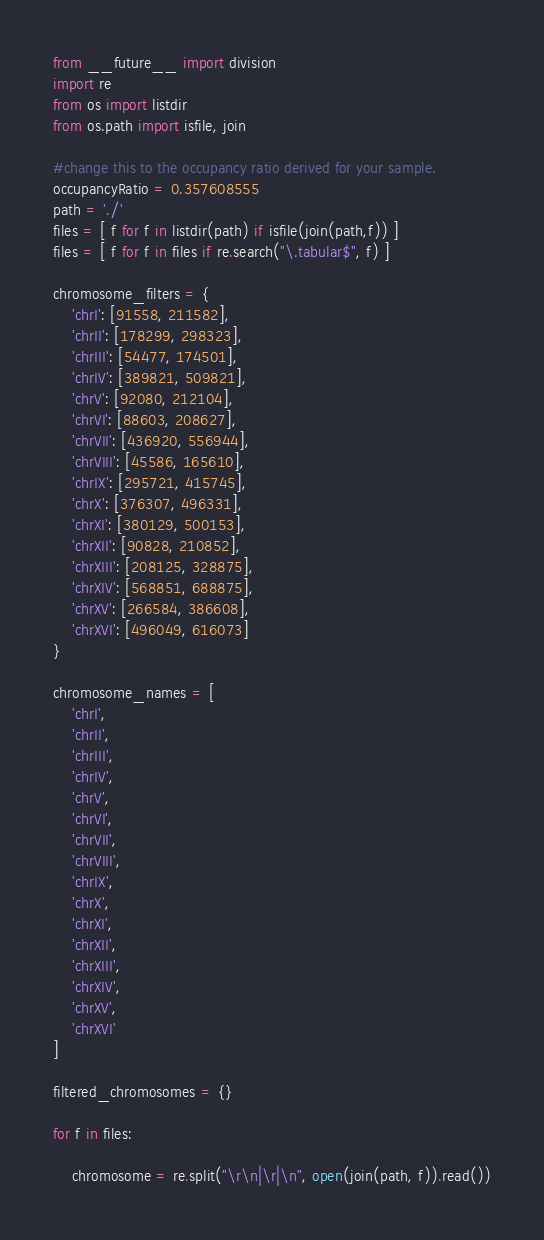Convert code to text. <code><loc_0><loc_0><loc_500><loc_500><_Python_>from __future__ import division
import re
from os import listdir
from os.path import isfile, join

#change this to the occupancy ratio derived for your sample.
occupancyRatio = 0.357608555
path = './'
files = [ f for f in listdir(path) if isfile(join(path,f)) ]
files = [ f for f in files if re.search("\.tabular$", f) ]

chromosome_filters = {
	'chrI': [91558, 211582],
	'chrII': [178299, 298323],
	'chrIII': [54477, 174501],
	'chrIV': [389821, 509821],
	'chrV': [92080, 212104],
	'chrVI': [88603, 208627],
	'chrVII': [436920, 556944],
	'chrVIII': [45586, 165610],
	'chrIX': [295721, 415745],
	'chrX': [376307, 496331],
	'chrXI': [380129, 500153],
	'chrXII': [90828, 210852],
	'chrXIII': [208125, 328875],
	'chrXIV': [568851, 688875],
	'chrXV': [266584, 386608],
	'chrXVI': [496049, 616073]
}

chromosome_names = [
	'chrI',
	'chrII',
	'chrIII',
	'chrIV',
	'chrV',
	'chrVI',
	'chrVII',
	'chrVIII',
	'chrIX',
	'chrX',
	'chrXI',
	'chrXII',
	'chrXIII',
	'chrXIV',
	'chrXV',
	'chrXVI'
]

filtered_chromosomes = {}

for f in files:

	chromosome = re.split("\r\n|\r|\n", open(join(path, f)).read())
</code> 